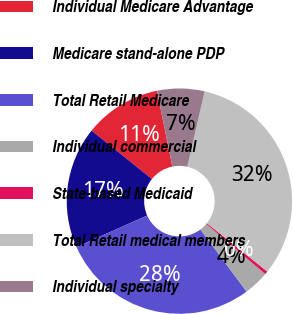Convert chart. <chart><loc_0><loc_0><loc_500><loc_500><pie_chart><fcel>Individual Medicare Advantage<fcel>Medicare stand-alone PDP<fcel>Total Retail Medicare<fcel>Individual commercial<fcel>State-based Medicaid<fcel>Total Retail medical members<fcel>Individual specialty<nl><fcel>11.04%<fcel>17.45%<fcel>28.49%<fcel>3.63%<fcel>0.46%<fcel>32.15%<fcel>6.79%<nl></chart> 